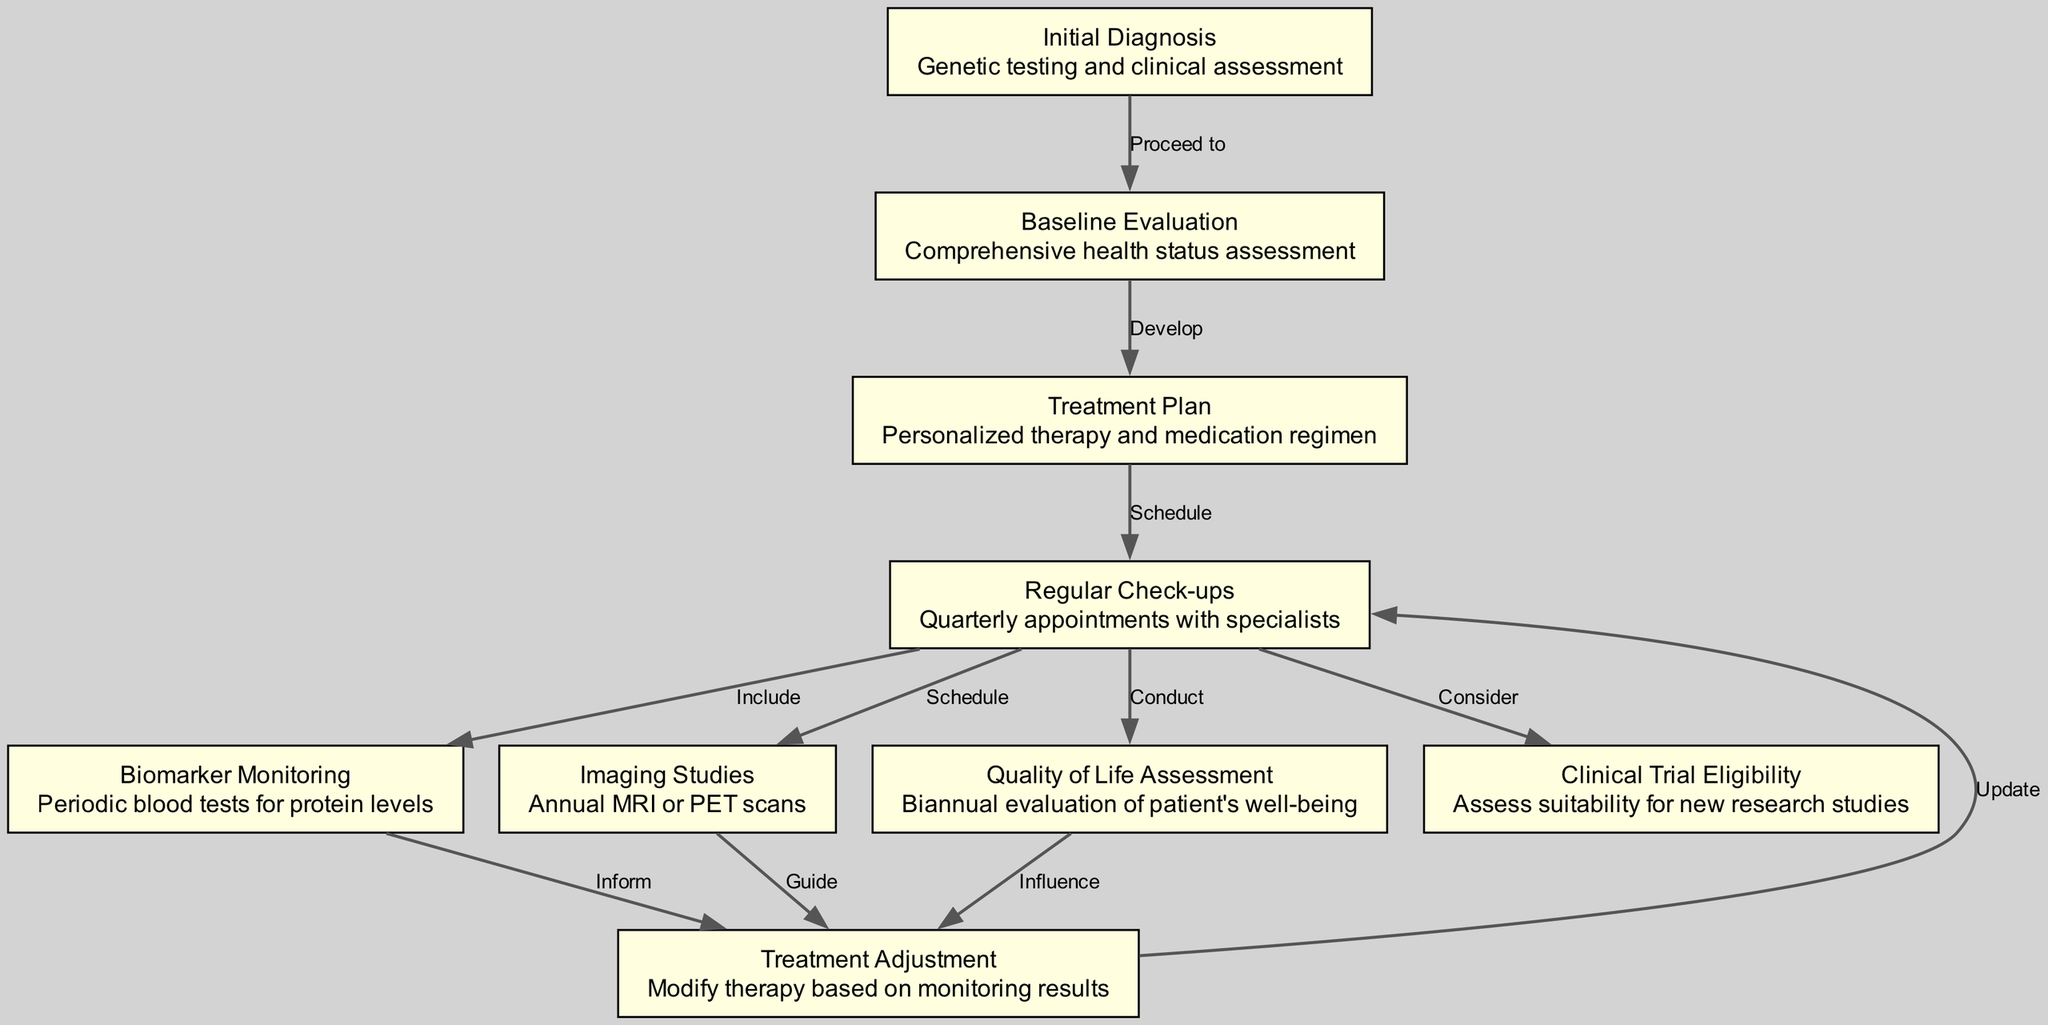What is the starting point of the clinical pathway? The starting point is "Initial Diagnosis," which involves genetic testing and clinical assessment. This is where the pathway begins before any evaluations or treatments.
Answer: Initial Diagnosis How many nodes are there in the diagram? The diagram contains a total of nine nodes, which represent various steps in the clinical pathway for managing chronic protein misfolding diseases.
Answer: 9 What do you conduct every six months according to the pathway? According to the pathway, a "Quality of Life Assessment" is conducted biannually to evaluate the patient's well-being.
Answer: Quality of Life Assessment What does the "Baseline Evaluation" lead to? The "Baseline Evaluation," which assesses overall health status, leads to the development of a "Treatment Plan" that outlines personalized therapy and medication regimens.
Answer: Treatment Plan What is informed by "Biomarker Monitoring"? "Biomarker Monitoring," which involves periodic blood tests for protein levels, informs "Treatment Adjustment" based on the monitoring results.
Answer: Treatment Adjustment Which node in the pathway involves quarterly appointments with specialists? The node involving quarterly appointments with specialists is "Regular Check-ups," which is essential for ongoing patient monitoring and care.
Answer: Regular Check-ups What does the "Imaging Studies" node indicate about the frequency of scans? The "Imaging Studies" node indicates that annual MRI or PET scans are scheduled as part of the patient's monitoring routine.
Answer: Annual MRI or PET scans What leads to the possibility of new research studies? The pathway suggests that after "Regular Check-ups," patients should "Consider" "Clinical Trial Eligibility," assessing their suitability for new research studies in the field of protein misfolding diseases.
Answer: Clinical Trial Eligibility What influences the "Treatment Adjustment"? "Treatment Adjustment" is influenced by the outcomes of "Biomarker Monitoring," "Imaging Studies," and the "Quality of Life Assessment," which collectively determine necessary modifications in therapy.
Answer: Quality of Life Assessment, Biomarker Monitoring, Imaging Studies 